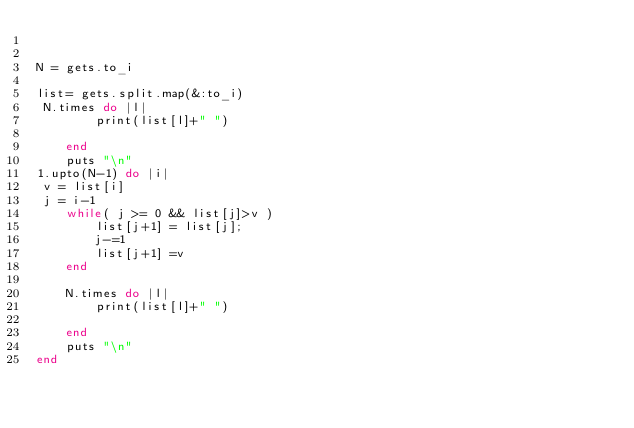Convert code to text. <code><loc_0><loc_0><loc_500><loc_500><_Ruby_>

N = gets.to_i

list= gets.split.map(&:to_i)
 N.times do |l|
    	print(list[l]+" ")

    end
    puts "\n"
1.upto(N-1) do |i|
 v = list[i]
 j = i-1
    while( j >= 0 && list[j]>v )
    	list[j+1] = list[j];
    	j-=1
    	list[j+1] =v
    end

    N.times do |l|
    	print(list[l]+" ")

    end
    puts "\n"
end</code> 